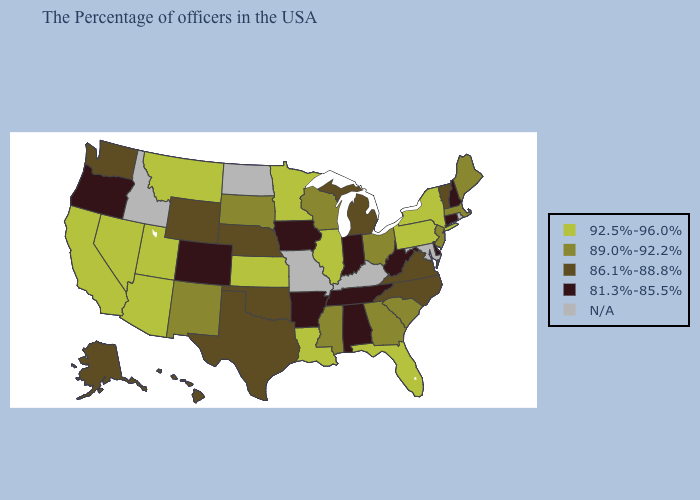What is the value of Vermont?
Keep it brief. 86.1%-88.8%. Name the states that have a value in the range N/A?
Quick response, please. Rhode Island, Maryland, Kentucky, Missouri, North Dakota, Idaho. Name the states that have a value in the range N/A?
Short answer required. Rhode Island, Maryland, Kentucky, Missouri, North Dakota, Idaho. Among the states that border Nevada , does Oregon have the highest value?
Be succinct. No. What is the value of South Carolina?
Give a very brief answer. 89.0%-92.2%. Does the map have missing data?
Write a very short answer. Yes. Name the states that have a value in the range 86.1%-88.8%?
Be succinct. Vermont, Virginia, North Carolina, Michigan, Nebraska, Oklahoma, Texas, Wyoming, Washington, Alaska, Hawaii. Which states have the highest value in the USA?
Quick response, please. New York, Pennsylvania, Florida, Illinois, Louisiana, Minnesota, Kansas, Utah, Montana, Arizona, Nevada, California. What is the highest value in the MidWest ?
Answer briefly. 92.5%-96.0%. Among the states that border Louisiana , which have the lowest value?
Short answer required. Arkansas. What is the value of Minnesota?
Quick response, please. 92.5%-96.0%. 